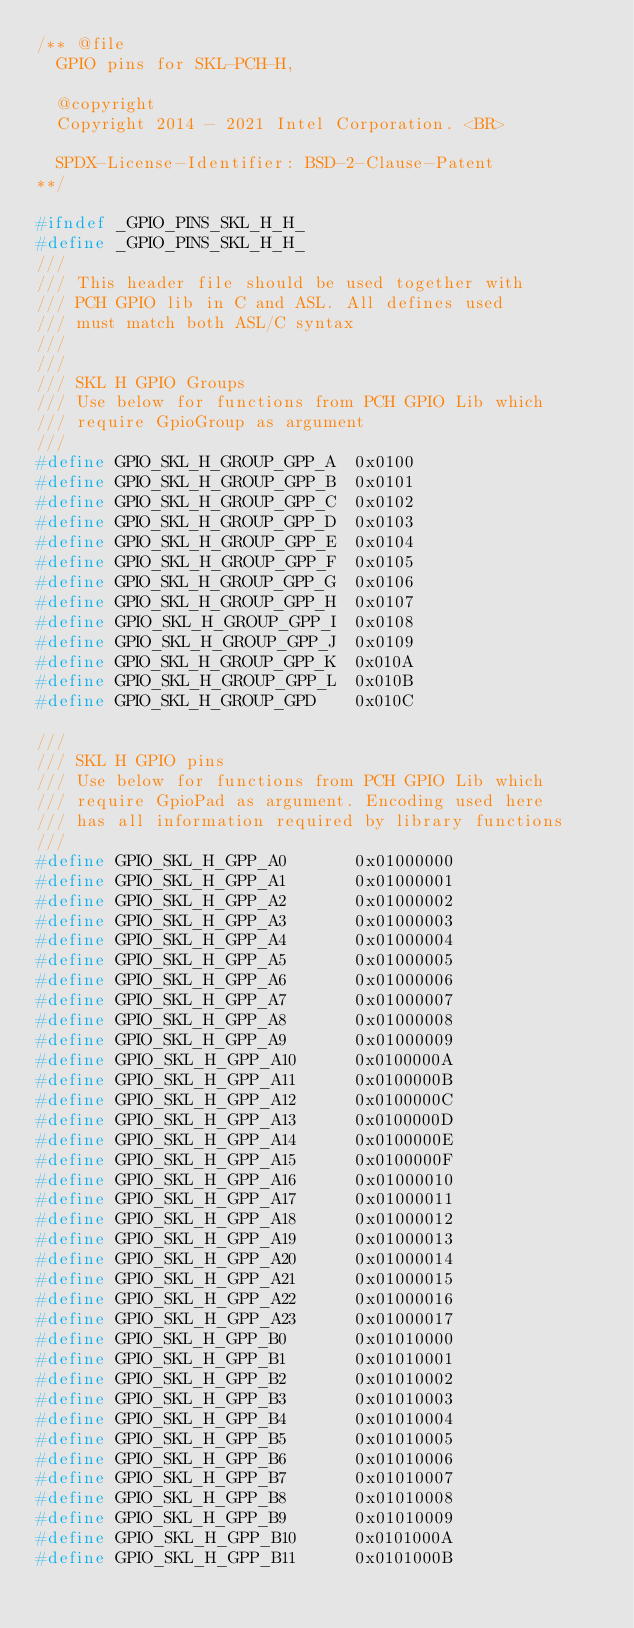Convert code to text. <code><loc_0><loc_0><loc_500><loc_500><_C_>/** @file
  GPIO pins for SKL-PCH-H,

  @copyright
  Copyright 2014 - 2021 Intel Corporation. <BR>

  SPDX-License-Identifier: BSD-2-Clause-Patent
**/

#ifndef _GPIO_PINS_SKL_H_H_
#define _GPIO_PINS_SKL_H_H_
///
/// This header file should be used together with
/// PCH GPIO lib in C and ASL. All defines used
/// must match both ASL/C syntax
///
///
/// SKL H GPIO Groups
/// Use below for functions from PCH GPIO Lib which
/// require GpioGroup as argument
///
#define GPIO_SKL_H_GROUP_GPP_A  0x0100
#define GPIO_SKL_H_GROUP_GPP_B  0x0101
#define GPIO_SKL_H_GROUP_GPP_C  0x0102
#define GPIO_SKL_H_GROUP_GPP_D  0x0103
#define GPIO_SKL_H_GROUP_GPP_E  0x0104
#define GPIO_SKL_H_GROUP_GPP_F  0x0105
#define GPIO_SKL_H_GROUP_GPP_G  0x0106
#define GPIO_SKL_H_GROUP_GPP_H  0x0107
#define GPIO_SKL_H_GROUP_GPP_I  0x0108
#define GPIO_SKL_H_GROUP_GPP_J  0x0109
#define GPIO_SKL_H_GROUP_GPP_K  0x010A
#define GPIO_SKL_H_GROUP_GPP_L  0x010B
#define GPIO_SKL_H_GROUP_GPD    0x010C

///
/// SKL H GPIO pins
/// Use below for functions from PCH GPIO Lib which
/// require GpioPad as argument. Encoding used here
/// has all information required by library functions
///
#define GPIO_SKL_H_GPP_A0       0x01000000
#define GPIO_SKL_H_GPP_A1       0x01000001
#define GPIO_SKL_H_GPP_A2       0x01000002
#define GPIO_SKL_H_GPP_A3       0x01000003
#define GPIO_SKL_H_GPP_A4       0x01000004
#define GPIO_SKL_H_GPP_A5       0x01000005
#define GPIO_SKL_H_GPP_A6       0x01000006
#define GPIO_SKL_H_GPP_A7       0x01000007
#define GPIO_SKL_H_GPP_A8       0x01000008
#define GPIO_SKL_H_GPP_A9       0x01000009
#define GPIO_SKL_H_GPP_A10      0x0100000A
#define GPIO_SKL_H_GPP_A11      0x0100000B
#define GPIO_SKL_H_GPP_A12      0x0100000C
#define GPIO_SKL_H_GPP_A13      0x0100000D
#define GPIO_SKL_H_GPP_A14      0x0100000E
#define GPIO_SKL_H_GPP_A15      0x0100000F
#define GPIO_SKL_H_GPP_A16      0x01000010
#define GPIO_SKL_H_GPP_A17      0x01000011
#define GPIO_SKL_H_GPP_A18      0x01000012
#define GPIO_SKL_H_GPP_A19      0x01000013
#define GPIO_SKL_H_GPP_A20      0x01000014
#define GPIO_SKL_H_GPP_A21      0x01000015
#define GPIO_SKL_H_GPP_A22      0x01000016
#define GPIO_SKL_H_GPP_A23      0x01000017
#define GPIO_SKL_H_GPP_B0       0x01010000
#define GPIO_SKL_H_GPP_B1       0x01010001
#define GPIO_SKL_H_GPP_B2       0x01010002
#define GPIO_SKL_H_GPP_B3       0x01010003
#define GPIO_SKL_H_GPP_B4       0x01010004
#define GPIO_SKL_H_GPP_B5       0x01010005
#define GPIO_SKL_H_GPP_B6       0x01010006
#define GPIO_SKL_H_GPP_B7       0x01010007
#define GPIO_SKL_H_GPP_B8       0x01010008
#define GPIO_SKL_H_GPP_B9       0x01010009
#define GPIO_SKL_H_GPP_B10      0x0101000A
#define GPIO_SKL_H_GPP_B11      0x0101000B</code> 